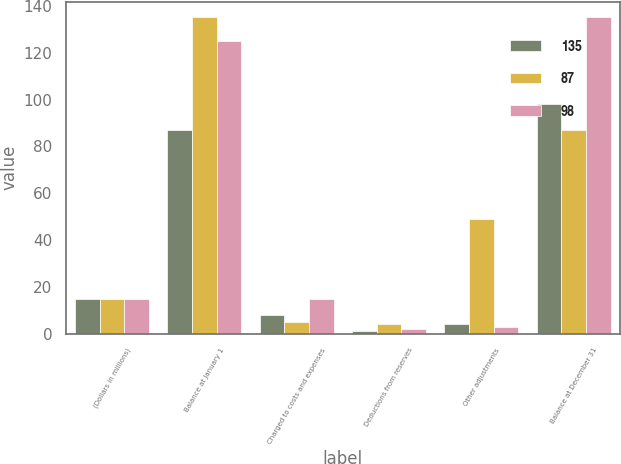Convert chart. <chart><loc_0><loc_0><loc_500><loc_500><stacked_bar_chart><ecel><fcel>(Dollars in millions)<fcel>Balance at January 1<fcel>Charged to costs and expenses<fcel>Deductions from reserves<fcel>Other adjustments<fcel>Balance at December 31<nl><fcel>135<fcel>15<fcel>87<fcel>8<fcel>1<fcel>4<fcel>98<nl><fcel>87<fcel>15<fcel>135<fcel>5<fcel>4<fcel>49<fcel>87<nl><fcel>98<fcel>15<fcel>125<fcel>15<fcel>2<fcel>3<fcel>135<nl></chart> 